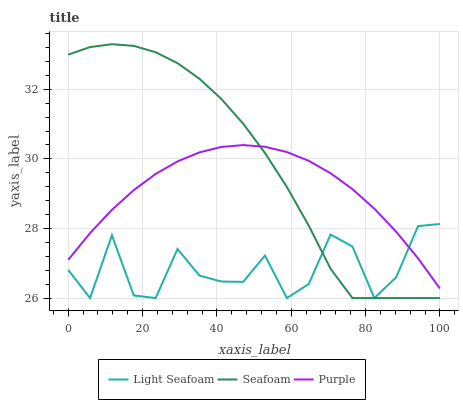Does Light Seafoam have the minimum area under the curve?
Answer yes or no. Yes. Does Seafoam have the maximum area under the curve?
Answer yes or no. Yes. Does Seafoam have the minimum area under the curve?
Answer yes or no. No. Does Light Seafoam have the maximum area under the curve?
Answer yes or no. No. Is Purple the smoothest?
Answer yes or no. Yes. Is Light Seafoam the roughest?
Answer yes or no. Yes. Is Seafoam the smoothest?
Answer yes or no. No. Is Seafoam the roughest?
Answer yes or no. No. Does Light Seafoam have the lowest value?
Answer yes or no. Yes. Does Seafoam have the highest value?
Answer yes or no. Yes. Does Light Seafoam have the highest value?
Answer yes or no. No. Does Purple intersect Light Seafoam?
Answer yes or no. Yes. Is Purple less than Light Seafoam?
Answer yes or no. No. Is Purple greater than Light Seafoam?
Answer yes or no. No. 